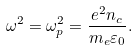<formula> <loc_0><loc_0><loc_500><loc_500>\omega ^ { 2 } = \omega _ { p } ^ { 2 } = \frac { e ^ { 2 } n _ { c } } { m _ { e } \varepsilon _ { 0 } } .</formula> 